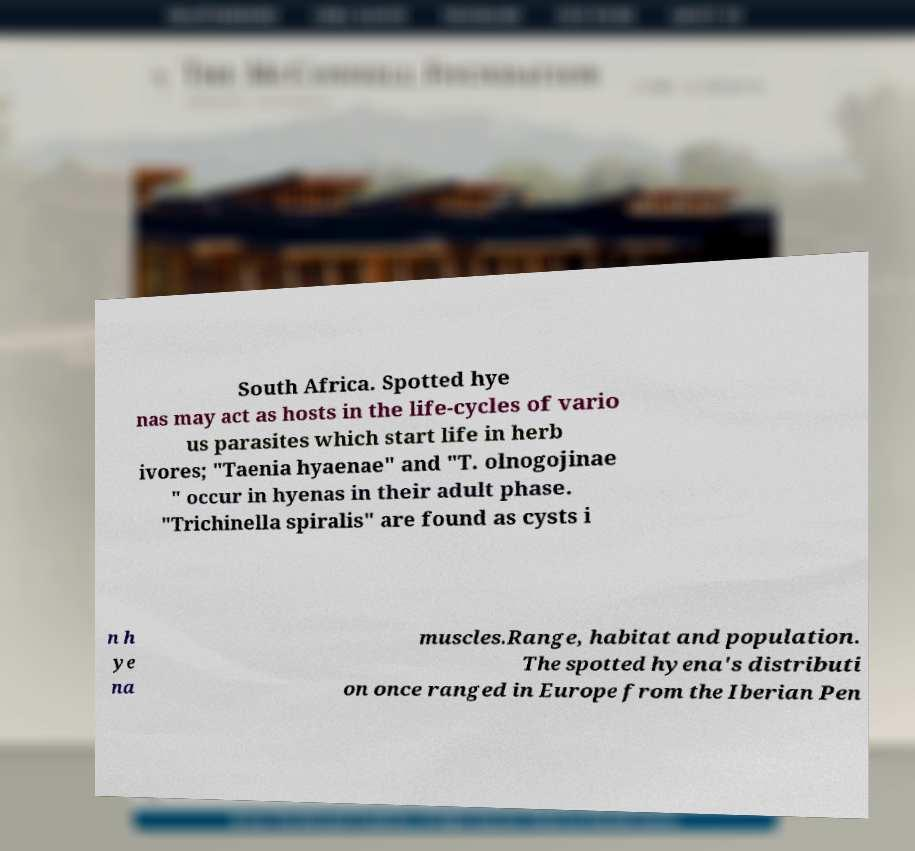Please read and relay the text visible in this image. What does it say? South Africa. Spotted hye nas may act as hosts in the life-cycles of vario us parasites which start life in herb ivores; "Taenia hyaenae" and "T. olnogojinae " occur in hyenas in their adult phase. "Trichinella spiralis" are found as cysts i n h ye na muscles.Range, habitat and population. The spotted hyena's distributi on once ranged in Europe from the Iberian Pen 